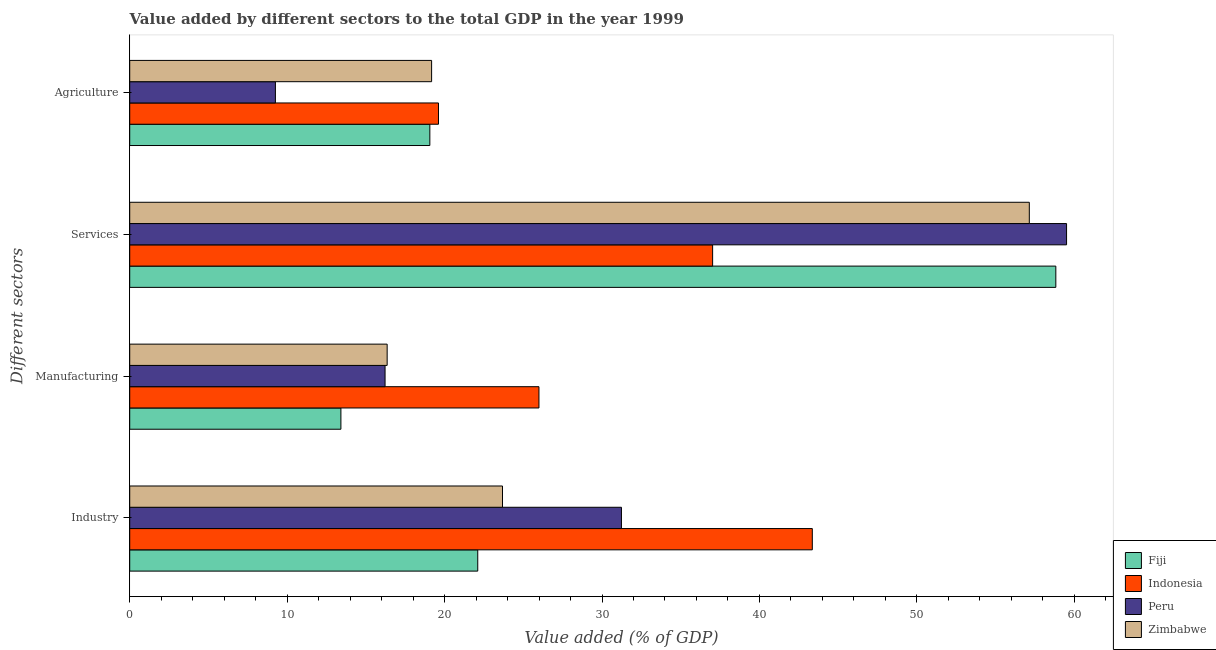How many groups of bars are there?
Your answer should be compact. 4. Are the number of bars on each tick of the Y-axis equal?
Your response must be concise. Yes. How many bars are there on the 4th tick from the bottom?
Provide a succinct answer. 4. What is the label of the 4th group of bars from the top?
Keep it short and to the point. Industry. What is the value added by services sector in Fiji?
Provide a short and direct response. 58.83. Across all countries, what is the maximum value added by manufacturing sector?
Provide a succinct answer. 25.99. Across all countries, what is the minimum value added by agricultural sector?
Your answer should be compact. 9.25. What is the total value added by services sector in the graph?
Ensure brevity in your answer.  212.51. What is the difference between the value added by agricultural sector in Zimbabwe and that in Fiji?
Offer a very short reply. 0.11. What is the difference between the value added by services sector in Indonesia and the value added by manufacturing sector in Zimbabwe?
Provide a short and direct response. 20.67. What is the average value added by industrial sector per country?
Give a very brief answer. 30.1. What is the difference between the value added by manufacturing sector and value added by services sector in Zimbabwe?
Make the answer very short. -40.79. In how many countries, is the value added by industrial sector greater than 48 %?
Give a very brief answer. 0. What is the ratio of the value added by agricultural sector in Peru to that in Indonesia?
Your response must be concise. 0.47. Is the value added by manufacturing sector in Peru less than that in Fiji?
Your answer should be very brief. No. What is the difference between the highest and the second highest value added by industrial sector?
Your response must be concise. 12.12. What is the difference between the highest and the lowest value added by industrial sector?
Offer a terse response. 21.25. What does the 3rd bar from the top in Agriculture represents?
Give a very brief answer. Indonesia. What does the 4th bar from the bottom in Agriculture represents?
Your response must be concise. Zimbabwe. How many bars are there?
Keep it short and to the point. 16. Are all the bars in the graph horizontal?
Keep it short and to the point. Yes. Are the values on the major ticks of X-axis written in scientific E-notation?
Your answer should be compact. No. Does the graph contain any zero values?
Provide a short and direct response. No. How are the legend labels stacked?
Offer a terse response. Vertical. What is the title of the graph?
Offer a terse response. Value added by different sectors to the total GDP in the year 1999. Does "High income: OECD" appear as one of the legend labels in the graph?
Give a very brief answer. No. What is the label or title of the X-axis?
Offer a very short reply. Value added (% of GDP). What is the label or title of the Y-axis?
Give a very brief answer. Different sectors. What is the Value added (% of GDP) in Fiji in Industry?
Ensure brevity in your answer.  22.11. What is the Value added (% of GDP) of Indonesia in Industry?
Provide a short and direct response. 43.36. What is the Value added (% of GDP) of Peru in Industry?
Keep it short and to the point. 31.24. What is the Value added (% of GDP) in Zimbabwe in Industry?
Make the answer very short. 23.68. What is the Value added (% of GDP) of Fiji in Manufacturing?
Your answer should be very brief. 13.42. What is the Value added (% of GDP) in Indonesia in Manufacturing?
Provide a succinct answer. 25.99. What is the Value added (% of GDP) of Peru in Manufacturing?
Provide a short and direct response. 16.22. What is the Value added (% of GDP) in Zimbabwe in Manufacturing?
Offer a very short reply. 16.35. What is the Value added (% of GDP) in Fiji in Services?
Provide a succinct answer. 58.83. What is the Value added (% of GDP) in Indonesia in Services?
Make the answer very short. 37.03. What is the Value added (% of GDP) in Peru in Services?
Your response must be concise. 59.51. What is the Value added (% of GDP) of Zimbabwe in Services?
Offer a very short reply. 57.14. What is the Value added (% of GDP) of Fiji in Agriculture?
Offer a very short reply. 19.06. What is the Value added (% of GDP) of Indonesia in Agriculture?
Your response must be concise. 19.61. What is the Value added (% of GDP) of Peru in Agriculture?
Your response must be concise. 9.25. What is the Value added (% of GDP) of Zimbabwe in Agriculture?
Provide a short and direct response. 19.18. Across all Different sectors, what is the maximum Value added (% of GDP) in Fiji?
Your answer should be compact. 58.83. Across all Different sectors, what is the maximum Value added (% of GDP) of Indonesia?
Offer a terse response. 43.36. Across all Different sectors, what is the maximum Value added (% of GDP) in Peru?
Give a very brief answer. 59.51. Across all Different sectors, what is the maximum Value added (% of GDP) in Zimbabwe?
Offer a very short reply. 57.14. Across all Different sectors, what is the minimum Value added (% of GDP) of Fiji?
Offer a very short reply. 13.42. Across all Different sectors, what is the minimum Value added (% of GDP) in Indonesia?
Keep it short and to the point. 19.61. Across all Different sectors, what is the minimum Value added (% of GDP) in Peru?
Provide a short and direct response. 9.25. Across all Different sectors, what is the minimum Value added (% of GDP) of Zimbabwe?
Your answer should be very brief. 16.35. What is the total Value added (% of GDP) of Fiji in the graph?
Your response must be concise. 113.42. What is the total Value added (% of GDP) of Indonesia in the graph?
Give a very brief answer. 125.99. What is the total Value added (% of GDP) in Peru in the graph?
Offer a terse response. 116.22. What is the total Value added (% of GDP) in Zimbabwe in the graph?
Ensure brevity in your answer.  116.35. What is the difference between the Value added (% of GDP) of Fiji in Industry and that in Manufacturing?
Provide a short and direct response. 8.69. What is the difference between the Value added (% of GDP) in Indonesia in Industry and that in Manufacturing?
Ensure brevity in your answer.  17.37. What is the difference between the Value added (% of GDP) of Peru in Industry and that in Manufacturing?
Provide a short and direct response. 15.02. What is the difference between the Value added (% of GDP) of Zimbabwe in Industry and that in Manufacturing?
Keep it short and to the point. 7.33. What is the difference between the Value added (% of GDP) of Fiji in Industry and that in Services?
Your answer should be very brief. -36.72. What is the difference between the Value added (% of GDP) in Indonesia in Industry and that in Services?
Keep it short and to the point. 6.33. What is the difference between the Value added (% of GDP) in Peru in Industry and that in Services?
Offer a terse response. -28.27. What is the difference between the Value added (% of GDP) in Zimbabwe in Industry and that in Services?
Offer a very short reply. -33.46. What is the difference between the Value added (% of GDP) of Fiji in Industry and that in Agriculture?
Offer a terse response. 3.04. What is the difference between the Value added (% of GDP) of Indonesia in Industry and that in Agriculture?
Give a very brief answer. 23.75. What is the difference between the Value added (% of GDP) in Peru in Industry and that in Agriculture?
Make the answer very short. 21.98. What is the difference between the Value added (% of GDP) in Zimbabwe in Industry and that in Agriculture?
Make the answer very short. 4.5. What is the difference between the Value added (% of GDP) in Fiji in Manufacturing and that in Services?
Ensure brevity in your answer.  -45.41. What is the difference between the Value added (% of GDP) in Indonesia in Manufacturing and that in Services?
Your answer should be compact. -11.03. What is the difference between the Value added (% of GDP) in Peru in Manufacturing and that in Services?
Provide a succinct answer. -43.29. What is the difference between the Value added (% of GDP) in Zimbabwe in Manufacturing and that in Services?
Keep it short and to the point. -40.79. What is the difference between the Value added (% of GDP) of Fiji in Manufacturing and that in Agriculture?
Provide a succinct answer. -5.65. What is the difference between the Value added (% of GDP) of Indonesia in Manufacturing and that in Agriculture?
Offer a very short reply. 6.38. What is the difference between the Value added (% of GDP) of Peru in Manufacturing and that in Agriculture?
Ensure brevity in your answer.  6.97. What is the difference between the Value added (% of GDP) in Zimbabwe in Manufacturing and that in Agriculture?
Your response must be concise. -2.82. What is the difference between the Value added (% of GDP) of Fiji in Services and that in Agriculture?
Make the answer very short. 39.76. What is the difference between the Value added (% of GDP) of Indonesia in Services and that in Agriculture?
Offer a terse response. 17.41. What is the difference between the Value added (% of GDP) of Peru in Services and that in Agriculture?
Give a very brief answer. 50.26. What is the difference between the Value added (% of GDP) of Zimbabwe in Services and that in Agriculture?
Offer a terse response. 37.97. What is the difference between the Value added (% of GDP) in Fiji in Industry and the Value added (% of GDP) in Indonesia in Manufacturing?
Offer a terse response. -3.89. What is the difference between the Value added (% of GDP) of Fiji in Industry and the Value added (% of GDP) of Peru in Manufacturing?
Offer a terse response. 5.89. What is the difference between the Value added (% of GDP) in Fiji in Industry and the Value added (% of GDP) in Zimbabwe in Manufacturing?
Offer a very short reply. 5.76. What is the difference between the Value added (% of GDP) of Indonesia in Industry and the Value added (% of GDP) of Peru in Manufacturing?
Provide a succinct answer. 27.14. What is the difference between the Value added (% of GDP) in Indonesia in Industry and the Value added (% of GDP) in Zimbabwe in Manufacturing?
Your answer should be very brief. 27.01. What is the difference between the Value added (% of GDP) in Peru in Industry and the Value added (% of GDP) in Zimbabwe in Manufacturing?
Your answer should be very brief. 14.88. What is the difference between the Value added (% of GDP) in Fiji in Industry and the Value added (% of GDP) in Indonesia in Services?
Offer a very short reply. -14.92. What is the difference between the Value added (% of GDP) in Fiji in Industry and the Value added (% of GDP) in Peru in Services?
Provide a succinct answer. -37.4. What is the difference between the Value added (% of GDP) of Fiji in Industry and the Value added (% of GDP) of Zimbabwe in Services?
Provide a short and direct response. -35.04. What is the difference between the Value added (% of GDP) of Indonesia in Industry and the Value added (% of GDP) of Peru in Services?
Provide a short and direct response. -16.15. What is the difference between the Value added (% of GDP) of Indonesia in Industry and the Value added (% of GDP) of Zimbabwe in Services?
Your response must be concise. -13.78. What is the difference between the Value added (% of GDP) in Peru in Industry and the Value added (% of GDP) in Zimbabwe in Services?
Ensure brevity in your answer.  -25.91. What is the difference between the Value added (% of GDP) of Fiji in Industry and the Value added (% of GDP) of Indonesia in Agriculture?
Ensure brevity in your answer.  2.5. What is the difference between the Value added (% of GDP) of Fiji in Industry and the Value added (% of GDP) of Peru in Agriculture?
Offer a very short reply. 12.85. What is the difference between the Value added (% of GDP) in Fiji in Industry and the Value added (% of GDP) in Zimbabwe in Agriculture?
Make the answer very short. 2.93. What is the difference between the Value added (% of GDP) of Indonesia in Industry and the Value added (% of GDP) of Peru in Agriculture?
Your response must be concise. 34.11. What is the difference between the Value added (% of GDP) in Indonesia in Industry and the Value added (% of GDP) in Zimbabwe in Agriculture?
Give a very brief answer. 24.18. What is the difference between the Value added (% of GDP) of Peru in Industry and the Value added (% of GDP) of Zimbabwe in Agriculture?
Your answer should be very brief. 12.06. What is the difference between the Value added (% of GDP) of Fiji in Manufacturing and the Value added (% of GDP) of Indonesia in Services?
Ensure brevity in your answer.  -23.61. What is the difference between the Value added (% of GDP) of Fiji in Manufacturing and the Value added (% of GDP) of Peru in Services?
Your answer should be compact. -46.09. What is the difference between the Value added (% of GDP) in Fiji in Manufacturing and the Value added (% of GDP) in Zimbabwe in Services?
Make the answer very short. -43.73. What is the difference between the Value added (% of GDP) in Indonesia in Manufacturing and the Value added (% of GDP) in Peru in Services?
Make the answer very short. -33.52. What is the difference between the Value added (% of GDP) of Indonesia in Manufacturing and the Value added (% of GDP) of Zimbabwe in Services?
Offer a very short reply. -31.15. What is the difference between the Value added (% of GDP) of Peru in Manufacturing and the Value added (% of GDP) of Zimbabwe in Services?
Offer a terse response. -40.92. What is the difference between the Value added (% of GDP) in Fiji in Manufacturing and the Value added (% of GDP) in Indonesia in Agriculture?
Offer a terse response. -6.2. What is the difference between the Value added (% of GDP) in Fiji in Manufacturing and the Value added (% of GDP) in Peru in Agriculture?
Offer a terse response. 4.16. What is the difference between the Value added (% of GDP) of Fiji in Manufacturing and the Value added (% of GDP) of Zimbabwe in Agriculture?
Offer a very short reply. -5.76. What is the difference between the Value added (% of GDP) of Indonesia in Manufacturing and the Value added (% of GDP) of Peru in Agriculture?
Your response must be concise. 16.74. What is the difference between the Value added (% of GDP) of Indonesia in Manufacturing and the Value added (% of GDP) of Zimbabwe in Agriculture?
Keep it short and to the point. 6.82. What is the difference between the Value added (% of GDP) of Peru in Manufacturing and the Value added (% of GDP) of Zimbabwe in Agriculture?
Your response must be concise. -2.96. What is the difference between the Value added (% of GDP) in Fiji in Services and the Value added (% of GDP) in Indonesia in Agriculture?
Your response must be concise. 39.22. What is the difference between the Value added (% of GDP) in Fiji in Services and the Value added (% of GDP) in Peru in Agriculture?
Provide a short and direct response. 49.57. What is the difference between the Value added (% of GDP) in Fiji in Services and the Value added (% of GDP) in Zimbabwe in Agriculture?
Make the answer very short. 39.65. What is the difference between the Value added (% of GDP) in Indonesia in Services and the Value added (% of GDP) in Peru in Agriculture?
Ensure brevity in your answer.  27.77. What is the difference between the Value added (% of GDP) of Indonesia in Services and the Value added (% of GDP) of Zimbabwe in Agriculture?
Ensure brevity in your answer.  17.85. What is the difference between the Value added (% of GDP) of Peru in Services and the Value added (% of GDP) of Zimbabwe in Agriculture?
Keep it short and to the point. 40.33. What is the average Value added (% of GDP) of Fiji per Different sectors?
Offer a very short reply. 28.35. What is the average Value added (% of GDP) in Indonesia per Different sectors?
Make the answer very short. 31.5. What is the average Value added (% of GDP) in Peru per Different sectors?
Your response must be concise. 29.05. What is the average Value added (% of GDP) in Zimbabwe per Different sectors?
Your answer should be very brief. 29.09. What is the difference between the Value added (% of GDP) in Fiji and Value added (% of GDP) in Indonesia in Industry?
Your answer should be compact. -21.25. What is the difference between the Value added (% of GDP) of Fiji and Value added (% of GDP) of Peru in Industry?
Your answer should be very brief. -9.13. What is the difference between the Value added (% of GDP) of Fiji and Value added (% of GDP) of Zimbabwe in Industry?
Make the answer very short. -1.57. What is the difference between the Value added (% of GDP) of Indonesia and Value added (% of GDP) of Peru in Industry?
Keep it short and to the point. 12.12. What is the difference between the Value added (% of GDP) in Indonesia and Value added (% of GDP) in Zimbabwe in Industry?
Ensure brevity in your answer.  19.68. What is the difference between the Value added (% of GDP) of Peru and Value added (% of GDP) of Zimbabwe in Industry?
Offer a very short reply. 7.56. What is the difference between the Value added (% of GDP) of Fiji and Value added (% of GDP) of Indonesia in Manufacturing?
Your answer should be compact. -12.58. What is the difference between the Value added (% of GDP) of Fiji and Value added (% of GDP) of Peru in Manufacturing?
Ensure brevity in your answer.  -2.8. What is the difference between the Value added (% of GDP) in Fiji and Value added (% of GDP) in Zimbabwe in Manufacturing?
Provide a succinct answer. -2.94. What is the difference between the Value added (% of GDP) of Indonesia and Value added (% of GDP) of Peru in Manufacturing?
Your answer should be very brief. 9.77. What is the difference between the Value added (% of GDP) of Indonesia and Value added (% of GDP) of Zimbabwe in Manufacturing?
Ensure brevity in your answer.  9.64. What is the difference between the Value added (% of GDP) of Peru and Value added (% of GDP) of Zimbabwe in Manufacturing?
Make the answer very short. -0.13. What is the difference between the Value added (% of GDP) of Fiji and Value added (% of GDP) of Indonesia in Services?
Give a very brief answer. 21.8. What is the difference between the Value added (% of GDP) in Fiji and Value added (% of GDP) in Peru in Services?
Keep it short and to the point. -0.68. What is the difference between the Value added (% of GDP) in Fiji and Value added (% of GDP) in Zimbabwe in Services?
Your answer should be very brief. 1.68. What is the difference between the Value added (% of GDP) of Indonesia and Value added (% of GDP) of Peru in Services?
Your answer should be very brief. -22.48. What is the difference between the Value added (% of GDP) of Indonesia and Value added (% of GDP) of Zimbabwe in Services?
Ensure brevity in your answer.  -20.12. What is the difference between the Value added (% of GDP) in Peru and Value added (% of GDP) in Zimbabwe in Services?
Provide a short and direct response. 2.37. What is the difference between the Value added (% of GDP) in Fiji and Value added (% of GDP) in Indonesia in Agriculture?
Offer a terse response. -0.55. What is the difference between the Value added (% of GDP) in Fiji and Value added (% of GDP) in Peru in Agriculture?
Offer a terse response. 9.81. What is the difference between the Value added (% of GDP) in Fiji and Value added (% of GDP) in Zimbabwe in Agriculture?
Make the answer very short. -0.11. What is the difference between the Value added (% of GDP) of Indonesia and Value added (% of GDP) of Peru in Agriculture?
Your response must be concise. 10.36. What is the difference between the Value added (% of GDP) in Indonesia and Value added (% of GDP) in Zimbabwe in Agriculture?
Offer a very short reply. 0.44. What is the difference between the Value added (% of GDP) in Peru and Value added (% of GDP) in Zimbabwe in Agriculture?
Your answer should be compact. -9.92. What is the ratio of the Value added (% of GDP) of Fiji in Industry to that in Manufacturing?
Provide a short and direct response. 1.65. What is the ratio of the Value added (% of GDP) in Indonesia in Industry to that in Manufacturing?
Give a very brief answer. 1.67. What is the ratio of the Value added (% of GDP) in Peru in Industry to that in Manufacturing?
Ensure brevity in your answer.  1.93. What is the ratio of the Value added (% of GDP) of Zimbabwe in Industry to that in Manufacturing?
Your answer should be very brief. 1.45. What is the ratio of the Value added (% of GDP) in Fiji in Industry to that in Services?
Your answer should be compact. 0.38. What is the ratio of the Value added (% of GDP) in Indonesia in Industry to that in Services?
Provide a short and direct response. 1.17. What is the ratio of the Value added (% of GDP) in Peru in Industry to that in Services?
Make the answer very short. 0.52. What is the ratio of the Value added (% of GDP) of Zimbabwe in Industry to that in Services?
Keep it short and to the point. 0.41. What is the ratio of the Value added (% of GDP) of Fiji in Industry to that in Agriculture?
Offer a terse response. 1.16. What is the ratio of the Value added (% of GDP) in Indonesia in Industry to that in Agriculture?
Offer a terse response. 2.21. What is the ratio of the Value added (% of GDP) in Peru in Industry to that in Agriculture?
Provide a short and direct response. 3.38. What is the ratio of the Value added (% of GDP) in Zimbabwe in Industry to that in Agriculture?
Offer a terse response. 1.23. What is the ratio of the Value added (% of GDP) of Fiji in Manufacturing to that in Services?
Offer a very short reply. 0.23. What is the ratio of the Value added (% of GDP) in Indonesia in Manufacturing to that in Services?
Give a very brief answer. 0.7. What is the ratio of the Value added (% of GDP) of Peru in Manufacturing to that in Services?
Your answer should be compact. 0.27. What is the ratio of the Value added (% of GDP) in Zimbabwe in Manufacturing to that in Services?
Your answer should be very brief. 0.29. What is the ratio of the Value added (% of GDP) in Fiji in Manufacturing to that in Agriculture?
Your answer should be very brief. 0.7. What is the ratio of the Value added (% of GDP) in Indonesia in Manufacturing to that in Agriculture?
Your response must be concise. 1.33. What is the ratio of the Value added (% of GDP) of Peru in Manufacturing to that in Agriculture?
Keep it short and to the point. 1.75. What is the ratio of the Value added (% of GDP) of Zimbabwe in Manufacturing to that in Agriculture?
Your answer should be compact. 0.85. What is the ratio of the Value added (% of GDP) of Fiji in Services to that in Agriculture?
Keep it short and to the point. 3.09. What is the ratio of the Value added (% of GDP) of Indonesia in Services to that in Agriculture?
Offer a terse response. 1.89. What is the ratio of the Value added (% of GDP) of Peru in Services to that in Agriculture?
Your answer should be very brief. 6.43. What is the ratio of the Value added (% of GDP) in Zimbabwe in Services to that in Agriculture?
Provide a short and direct response. 2.98. What is the difference between the highest and the second highest Value added (% of GDP) in Fiji?
Offer a terse response. 36.72. What is the difference between the highest and the second highest Value added (% of GDP) of Indonesia?
Make the answer very short. 6.33. What is the difference between the highest and the second highest Value added (% of GDP) in Peru?
Your answer should be compact. 28.27. What is the difference between the highest and the second highest Value added (% of GDP) in Zimbabwe?
Keep it short and to the point. 33.46. What is the difference between the highest and the lowest Value added (% of GDP) in Fiji?
Your response must be concise. 45.41. What is the difference between the highest and the lowest Value added (% of GDP) in Indonesia?
Your answer should be compact. 23.75. What is the difference between the highest and the lowest Value added (% of GDP) of Peru?
Keep it short and to the point. 50.26. What is the difference between the highest and the lowest Value added (% of GDP) in Zimbabwe?
Offer a very short reply. 40.79. 